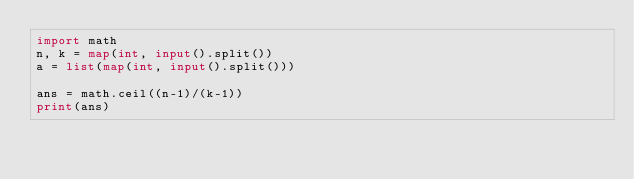Convert code to text. <code><loc_0><loc_0><loc_500><loc_500><_Python_>import math
n, k = map(int, input().split())
a = list(map(int, input().split()))

ans = math.ceil((n-1)/(k-1))
print(ans)</code> 